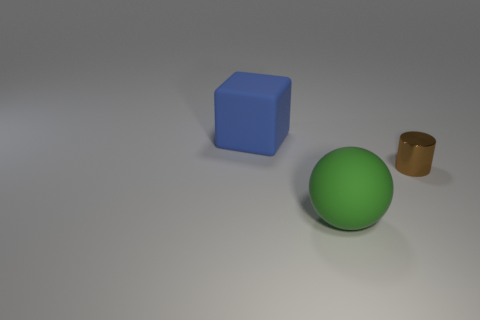Are there any other things that are the same size as the brown cylinder?
Keep it short and to the point. No. What number of objects are in front of the large cube and behind the metal object?
Make the answer very short. 0. Is there a sphere made of the same material as the big blue cube?
Your answer should be compact. Yes. There is a big thing to the right of the matte thing that is on the left side of the green sphere; what is its material?
Offer a very short reply. Rubber. Are there an equal number of big green rubber balls left of the blue object and big objects behind the matte ball?
Offer a terse response. No. Is the shape of the green rubber object the same as the tiny metal thing?
Offer a terse response. No. What is the thing that is on the right side of the blue thing and to the left of the small cylinder made of?
Your response must be concise. Rubber. How many other brown metallic things have the same shape as the small brown thing?
Provide a short and direct response. 0. There is a matte object behind the tiny brown cylinder right of the big thing in front of the large matte cube; what size is it?
Offer a very short reply. Large. Are there more large rubber things behind the large green matte object than tiny yellow matte cubes?
Keep it short and to the point. Yes. 